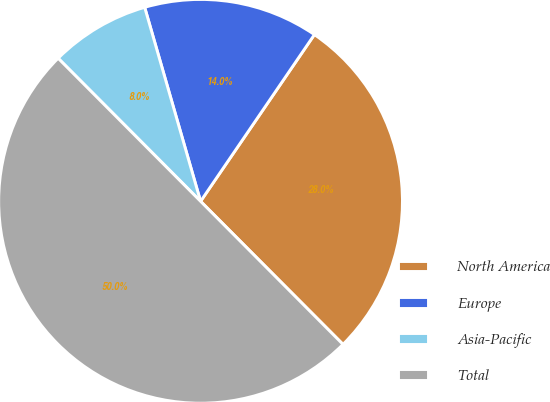Convert chart. <chart><loc_0><loc_0><loc_500><loc_500><pie_chart><fcel>North America<fcel>Europe<fcel>Asia-Pacific<fcel>Total<nl><fcel>28.0%<fcel>14.0%<fcel>8.0%<fcel>50.0%<nl></chart> 